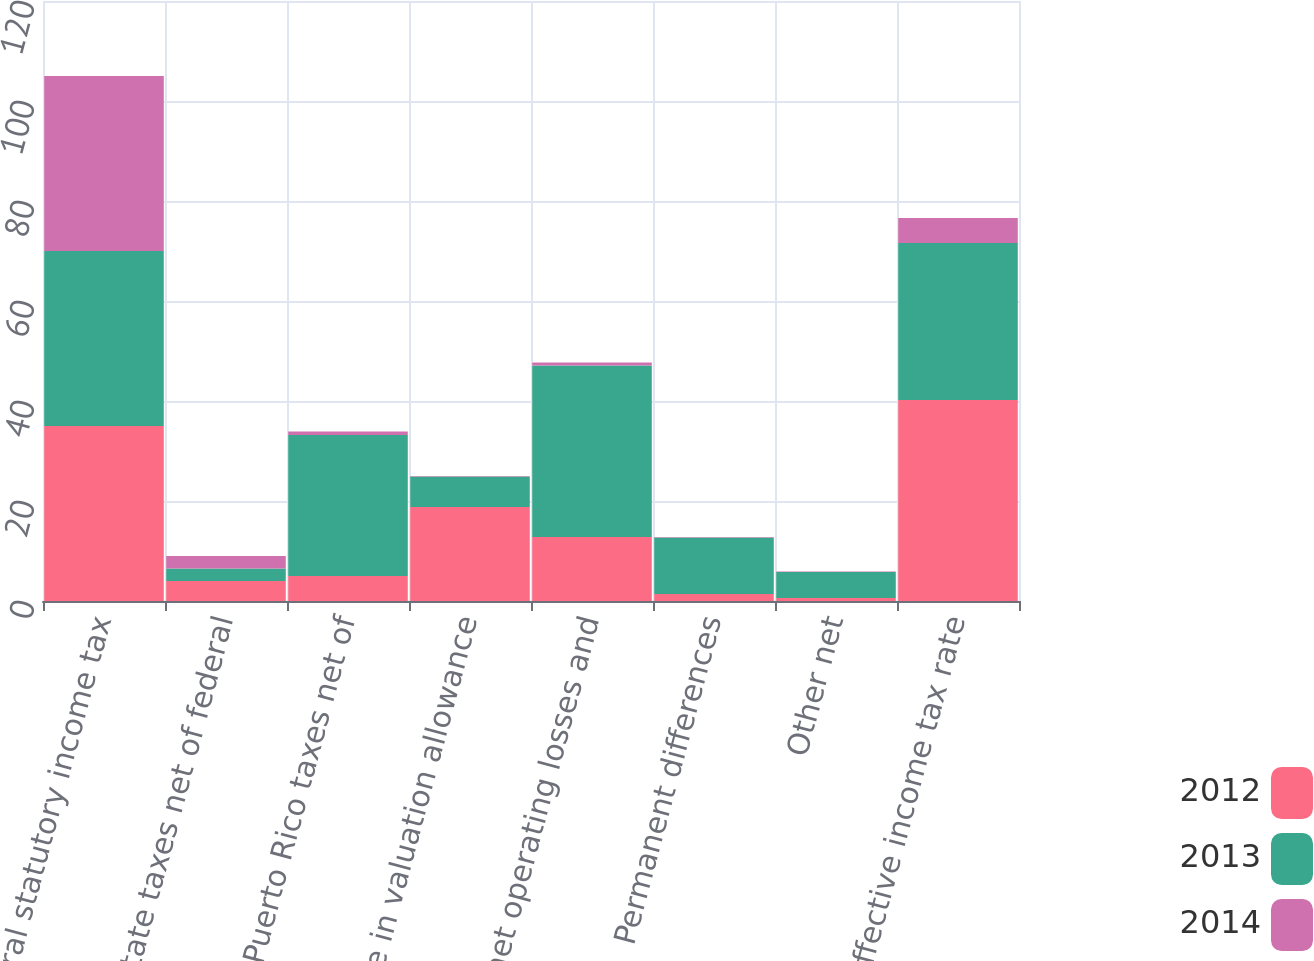Convert chart to OTSL. <chart><loc_0><loc_0><loc_500><loc_500><stacked_bar_chart><ecel><fcel>Federal statutory income tax<fcel>State taxes net of federal<fcel>Puerto Rico taxes net of<fcel>Change in valuation allowance<fcel>State net operating losses and<fcel>Permanent differences<fcel>Other net<fcel>Effective income tax rate<nl><fcel>2012<fcel>35<fcel>4<fcel>5<fcel>18.8<fcel>12.8<fcel>1.4<fcel>0.6<fcel>40.2<nl><fcel>2013<fcel>35<fcel>2.5<fcel>28.2<fcel>6.1<fcel>34.3<fcel>11.3<fcel>5.2<fcel>31.4<nl><fcel>2014<fcel>35<fcel>2.5<fcel>0.7<fcel>0.1<fcel>0.6<fcel>0.1<fcel>0.1<fcel>5<nl></chart> 